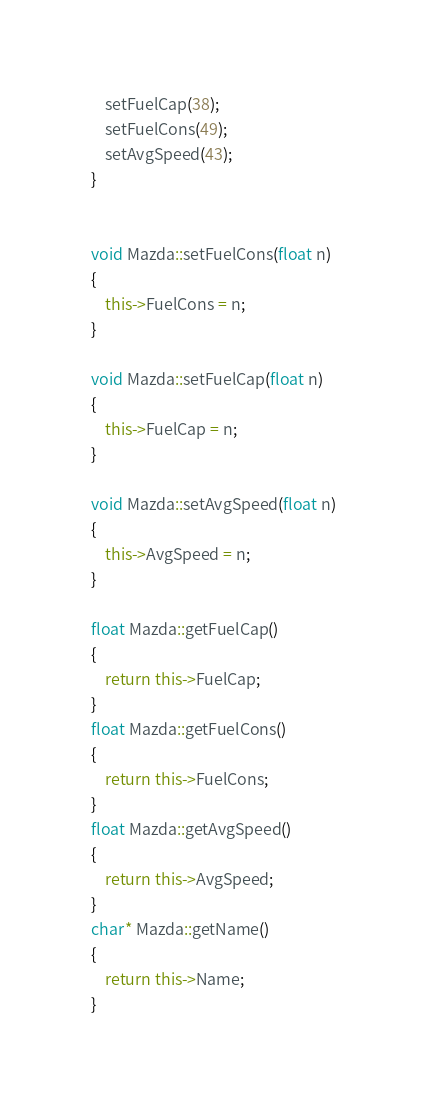<code> <loc_0><loc_0><loc_500><loc_500><_C++_>	setFuelCap(38);
	setFuelCons(49);
	setAvgSpeed(43);
}


void Mazda::setFuelCons(float n)
{
	this->FuelCons = n;
}

void Mazda::setFuelCap(float n)
{
	this->FuelCap = n;
}

void Mazda::setAvgSpeed(float n)
{
	this->AvgSpeed = n;
}

float Mazda::getFuelCap()
{
	return this->FuelCap;
}
float Mazda::getFuelCons()
{
	return this->FuelCons;
}
float Mazda::getAvgSpeed()
{
	return this->AvgSpeed;
}
char* Mazda::getName()
{
	return this->Name;
}</code> 